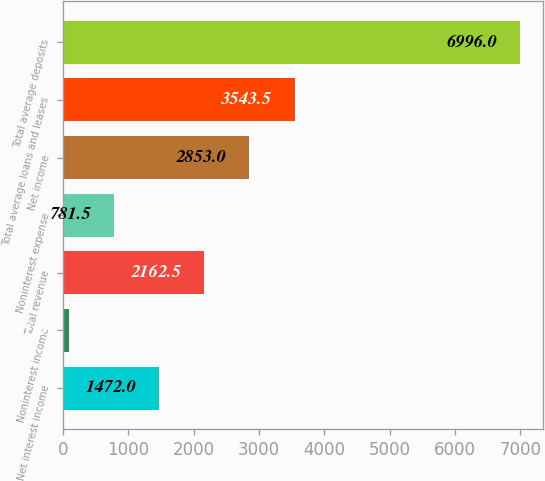Convert chart to OTSL. <chart><loc_0><loc_0><loc_500><loc_500><bar_chart><fcel>Net interest income<fcel>Noninterest income<fcel>Total revenue<fcel>Noninterest expense<fcel>Net income<fcel>Total average loans and leases<fcel>Total average deposits<nl><fcel>1472<fcel>91<fcel>2162.5<fcel>781.5<fcel>2853<fcel>3543.5<fcel>6996<nl></chart> 